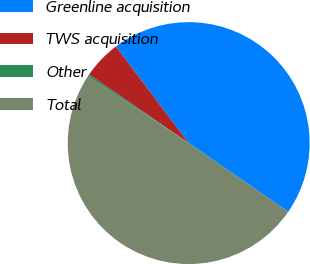Convert chart to OTSL. <chart><loc_0><loc_0><loc_500><loc_500><pie_chart><fcel>Greenline acquisition<fcel>TWS acquisition<fcel>Other<fcel>Total<nl><fcel>44.87%<fcel>5.13%<fcel>0.31%<fcel>49.69%<nl></chart> 